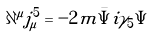Convert formula to latex. <formula><loc_0><loc_0><loc_500><loc_500>\partial ^ { \mu } j _ { \mu } ^ { 5 } = - 2 m \bar { \Psi } i \gamma _ { 5 } \Psi</formula> 